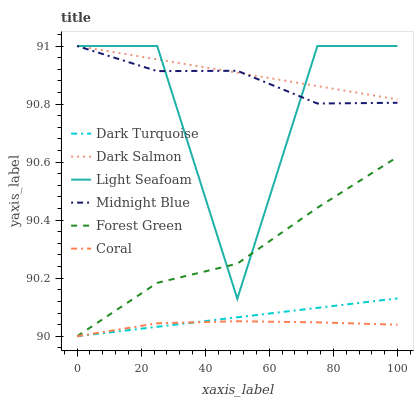Does Coral have the minimum area under the curve?
Answer yes or no. Yes. Does Dark Salmon have the maximum area under the curve?
Answer yes or no. Yes. Does Dark Turquoise have the minimum area under the curve?
Answer yes or no. No. Does Dark Turquoise have the maximum area under the curve?
Answer yes or no. No. Is Dark Turquoise the smoothest?
Answer yes or no. Yes. Is Light Seafoam the roughest?
Answer yes or no. Yes. Is Coral the smoothest?
Answer yes or no. No. Is Coral the roughest?
Answer yes or no. No. Does Dark Turquoise have the lowest value?
Answer yes or no. Yes. Does Dark Salmon have the lowest value?
Answer yes or no. No. Does Light Seafoam have the highest value?
Answer yes or no. Yes. Does Dark Turquoise have the highest value?
Answer yes or no. No. Is Dark Turquoise less than Light Seafoam?
Answer yes or no. Yes. Is Midnight Blue greater than Coral?
Answer yes or no. Yes. Does Dark Salmon intersect Light Seafoam?
Answer yes or no. Yes. Is Dark Salmon less than Light Seafoam?
Answer yes or no. No. Is Dark Salmon greater than Light Seafoam?
Answer yes or no. No. Does Dark Turquoise intersect Light Seafoam?
Answer yes or no. No. 